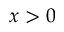<formula> <loc_0><loc_0><loc_500><loc_500>x > 0</formula> 